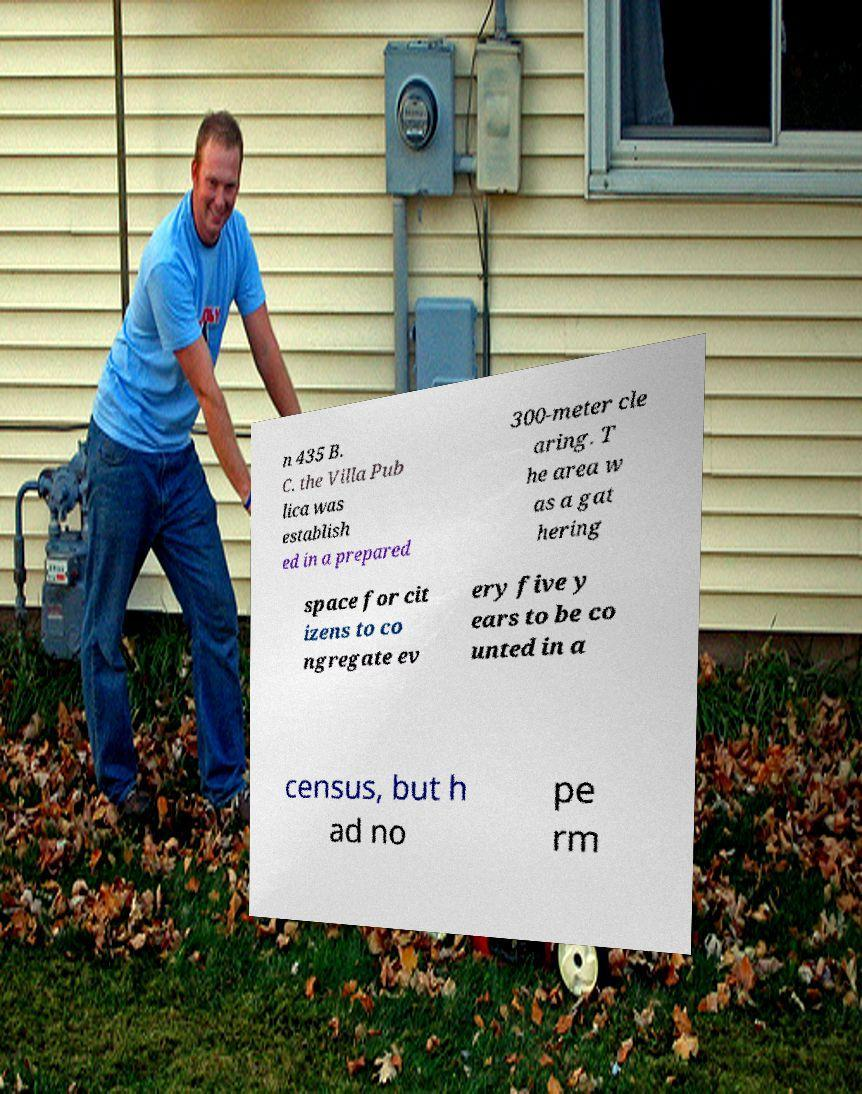Please read and relay the text visible in this image. What does it say? n 435 B. C. the Villa Pub lica was establish ed in a prepared 300-meter cle aring. T he area w as a gat hering space for cit izens to co ngregate ev ery five y ears to be co unted in a census, but h ad no pe rm 